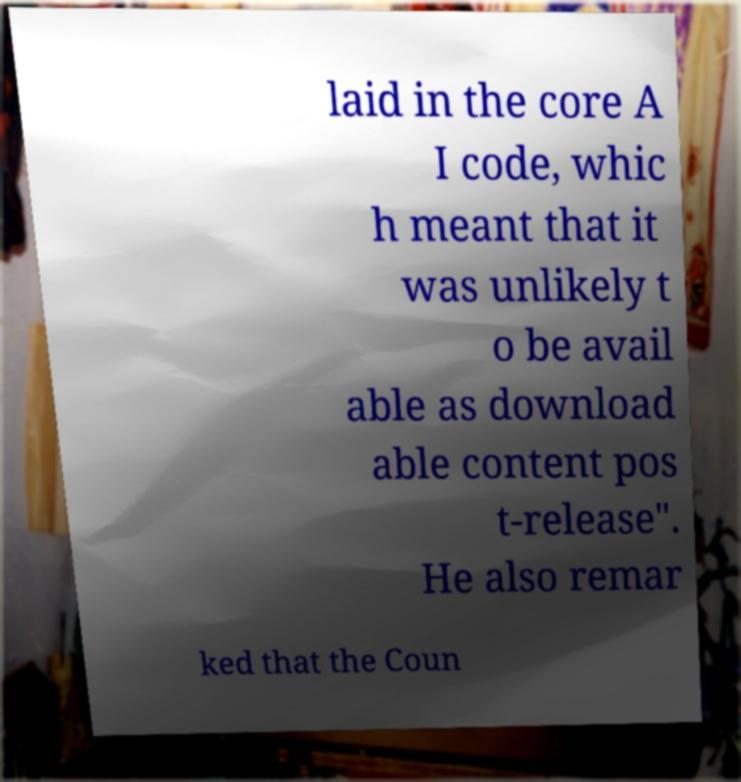Could you assist in decoding the text presented in this image and type it out clearly? laid in the core A I code, whic h meant that it was unlikely t o be avail able as download able content pos t-release". He also remar ked that the Coun 